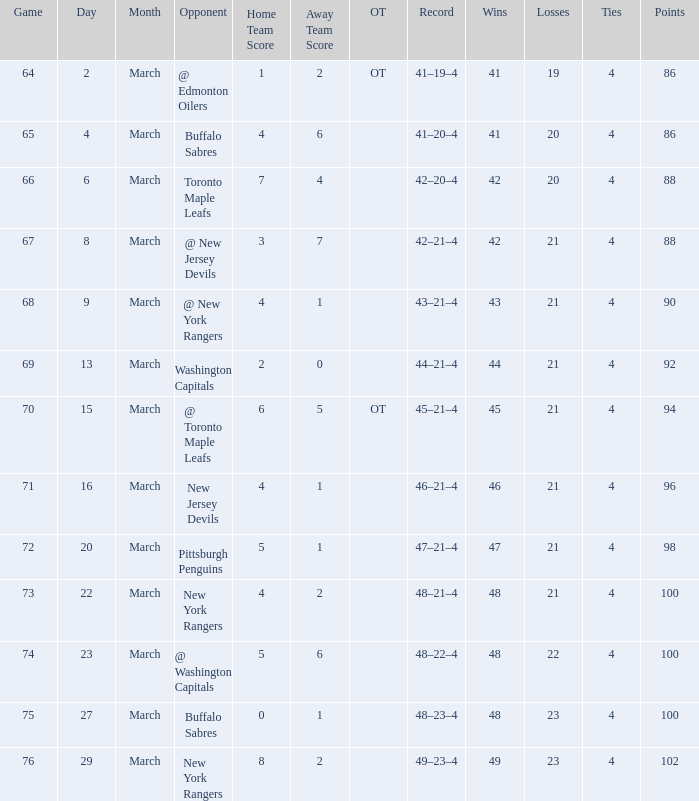Which March is the lowest one that has a Score of 5–6, and Points smaller than 100? None. 